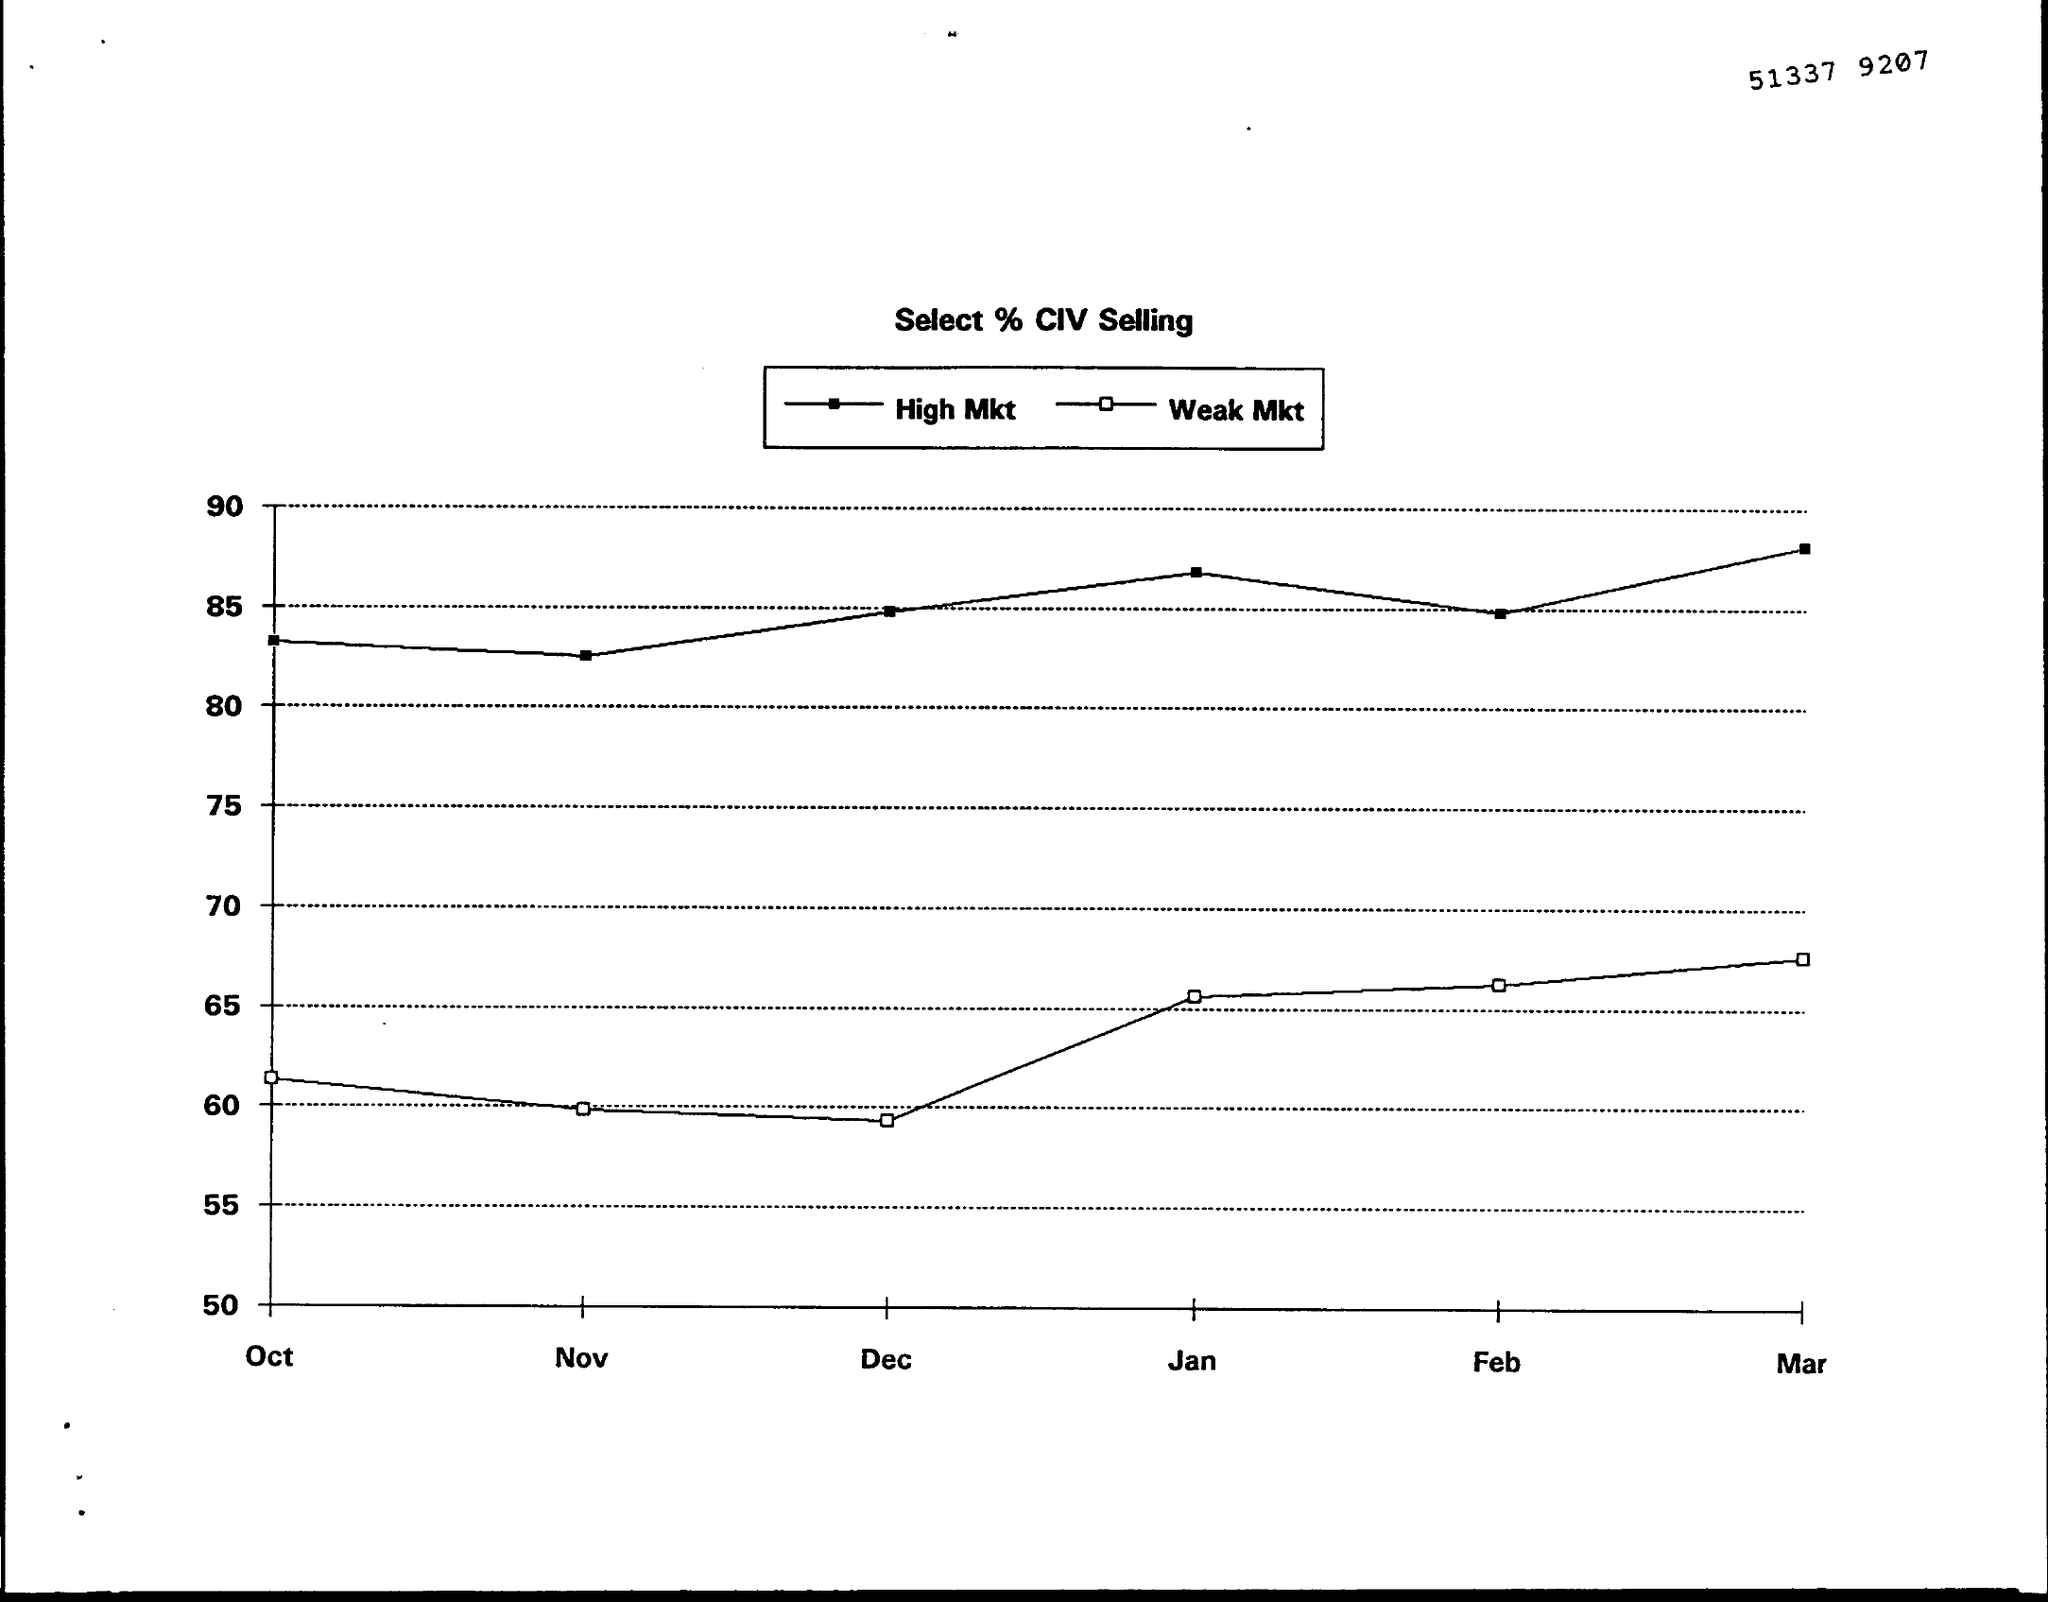Point out several critical features in this image. The number written at the top of the page is 51337 9207. The title of the graph is 'Select % CIV Selling..' 